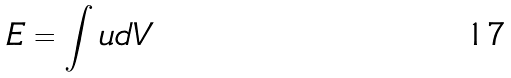<formula> <loc_0><loc_0><loc_500><loc_500>E = \int u d V</formula> 